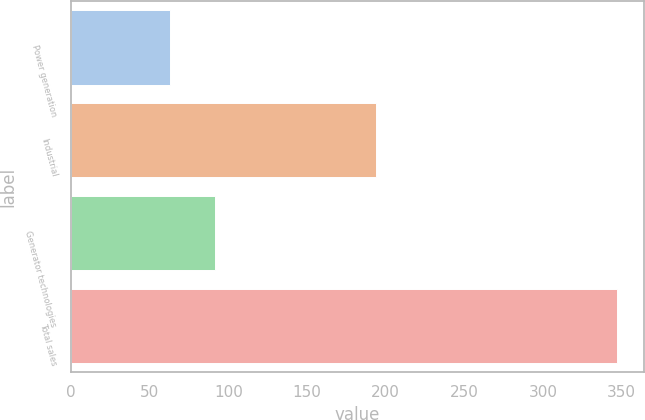Convert chart to OTSL. <chart><loc_0><loc_0><loc_500><loc_500><bar_chart><fcel>Power generation<fcel>Industrial<fcel>Generator technologies<fcel>Total sales<nl><fcel>63<fcel>194<fcel>91.4<fcel>347<nl></chart> 